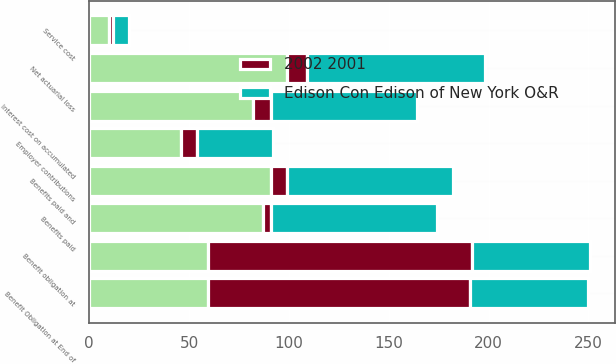Convert chart to OTSL. <chart><loc_0><loc_0><loc_500><loc_500><stacked_bar_chart><ecel><fcel>Benefit obligation at<fcel>Service cost<fcel>Interest cost on accumulated<fcel>Net actuarial loss<fcel>Benefits paid and<fcel>Benefit Obligation at End of<fcel>Employer contributions<fcel>Benefits paid<nl><fcel>nan<fcel>59.5<fcel>10<fcel>82<fcel>99<fcel>91<fcel>59.5<fcel>46<fcel>87<nl><fcel>Edison Con Edison of New York O&R<fcel>59.5<fcel>8<fcel>73<fcel>89<fcel>83<fcel>59.5<fcel>38<fcel>83<nl><fcel>2002 2001<fcel>132<fcel>2<fcel>9<fcel>10<fcel>8<fcel>131<fcel>8<fcel>4<nl></chart> 